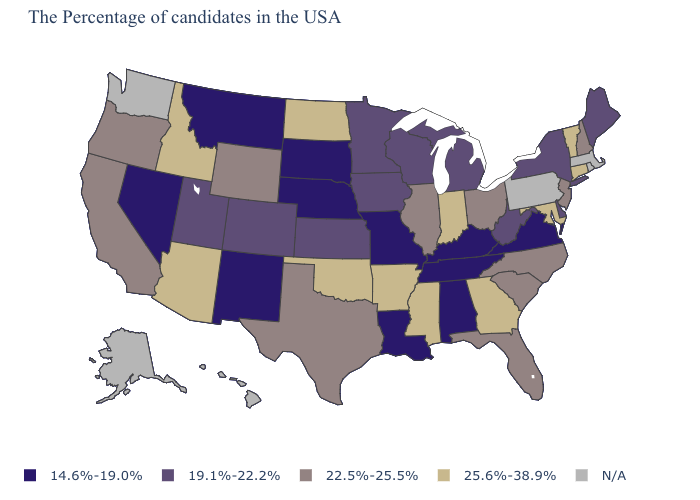Name the states that have a value in the range 14.6%-19.0%?
Write a very short answer. Virginia, Kentucky, Alabama, Tennessee, Louisiana, Missouri, Nebraska, South Dakota, New Mexico, Montana, Nevada. Which states have the lowest value in the South?
Quick response, please. Virginia, Kentucky, Alabama, Tennessee, Louisiana. What is the lowest value in the USA?
Short answer required. 14.6%-19.0%. What is the value of Pennsylvania?
Keep it brief. N/A. Which states have the highest value in the USA?
Keep it brief. Vermont, Connecticut, Maryland, Georgia, Indiana, Mississippi, Arkansas, Oklahoma, North Dakota, Arizona, Idaho. What is the highest value in the USA?
Keep it brief. 25.6%-38.9%. Does Nevada have the lowest value in the West?
Short answer required. Yes. What is the highest value in the USA?
Keep it brief. 25.6%-38.9%. Name the states that have a value in the range N/A?
Be succinct. Massachusetts, Rhode Island, Pennsylvania, Washington, Alaska, Hawaii. Is the legend a continuous bar?
Answer briefly. No. What is the highest value in the Northeast ?
Concise answer only. 25.6%-38.9%. Among the states that border New York , which have the lowest value?
Concise answer only. New Jersey. Name the states that have a value in the range 25.6%-38.9%?
Be succinct. Vermont, Connecticut, Maryland, Georgia, Indiana, Mississippi, Arkansas, Oklahoma, North Dakota, Arizona, Idaho. Among the states that border Florida , does Alabama have the highest value?
Concise answer only. No. What is the value of Texas?
Short answer required. 22.5%-25.5%. 